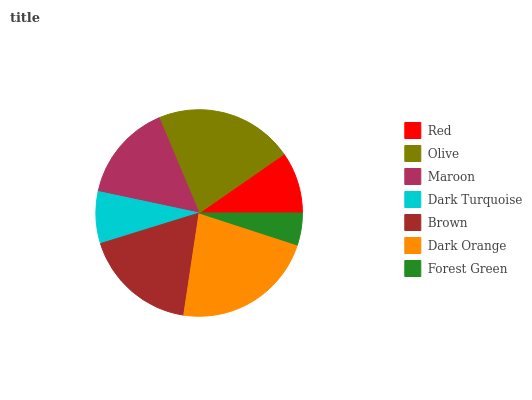Is Forest Green the minimum?
Answer yes or no. Yes. Is Dark Orange the maximum?
Answer yes or no. Yes. Is Olive the minimum?
Answer yes or no. No. Is Olive the maximum?
Answer yes or no. No. Is Olive greater than Red?
Answer yes or no. Yes. Is Red less than Olive?
Answer yes or no. Yes. Is Red greater than Olive?
Answer yes or no. No. Is Olive less than Red?
Answer yes or no. No. Is Maroon the high median?
Answer yes or no. Yes. Is Maroon the low median?
Answer yes or no. Yes. Is Olive the high median?
Answer yes or no. No. Is Forest Green the low median?
Answer yes or no. No. 